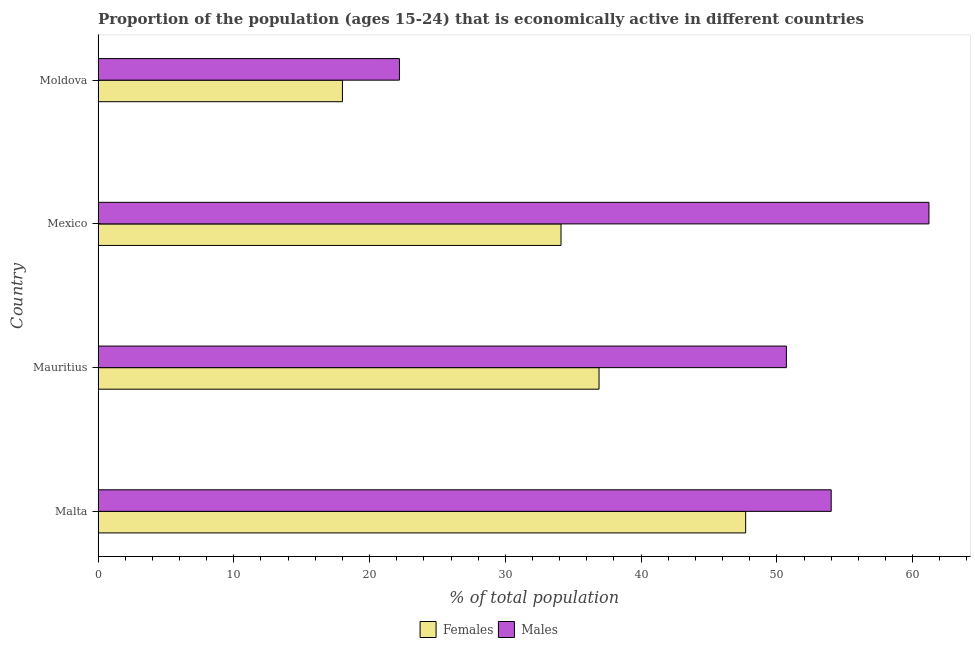How many different coloured bars are there?
Ensure brevity in your answer.  2. How many groups of bars are there?
Give a very brief answer. 4. Are the number of bars on each tick of the Y-axis equal?
Ensure brevity in your answer.  Yes. How many bars are there on the 4th tick from the top?
Provide a succinct answer. 2. What is the label of the 4th group of bars from the top?
Offer a terse response. Malta. In how many cases, is the number of bars for a given country not equal to the number of legend labels?
Offer a very short reply. 0. What is the percentage of economically active female population in Moldova?
Provide a short and direct response. 18. Across all countries, what is the maximum percentage of economically active male population?
Offer a terse response. 61.2. Across all countries, what is the minimum percentage of economically active female population?
Make the answer very short. 18. In which country was the percentage of economically active male population maximum?
Give a very brief answer. Mexico. In which country was the percentage of economically active female population minimum?
Your answer should be compact. Moldova. What is the total percentage of economically active male population in the graph?
Offer a terse response. 188.1. What is the difference between the percentage of economically active female population in Mexico and that in Moldova?
Keep it short and to the point. 16.1. What is the difference between the percentage of economically active male population in Moldova and the percentage of economically active female population in Malta?
Provide a short and direct response. -25.5. What is the average percentage of economically active female population per country?
Offer a terse response. 34.17. What is the ratio of the percentage of economically active female population in Malta to that in Mexico?
Your answer should be very brief. 1.4. Is the percentage of economically active female population in Mauritius less than that in Mexico?
Offer a very short reply. No. What is the difference between the highest and the second highest percentage of economically active female population?
Your response must be concise. 10.8. In how many countries, is the percentage of economically active female population greater than the average percentage of economically active female population taken over all countries?
Provide a short and direct response. 2. Is the sum of the percentage of economically active female population in Malta and Moldova greater than the maximum percentage of economically active male population across all countries?
Ensure brevity in your answer.  Yes. What does the 2nd bar from the top in Mexico represents?
Your response must be concise. Females. What does the 1st bar from the bottom in Mauritius represents?
Ensure brevity in your answer.  Females. How many bars are there?
Provide a succinct answer. 8. What is the difference between two consecutive major ticks on the X-axis?
Offer a very short reply. 10. Does the graph contain any zero values?
Provide a short and direct response. No. Does the graph contain grids?
Keep it short and to the point. No. Where does the legend appear in the graph?
Provide a succinct answer. Bottom center. How many legend labels are there?
Give a very brief answer. 2. What is the title of the graph?
Make the answer very short. Proportion of the population (ages 15-24) that is economically active in different countries. What is the label or title of the X-axis?
Provide a short and direct response. % of total population. What is the % of total population of Females in Malta?
Your answer should be very brief. 47.7. What is the % of total population in Females in Mauritius?
Make the answer very short. 36.9. What is the % of total population of Males in Mauritius?
Offer a very short reply. 50.7. What is the % of total population of Females in Mexico?
Ensure brevity in your answer.  34.1. What is the % of total population in Males in Mexico?
Offer a terse response. 61.2. What is the % of total population of Females in Moldova?
Provide a succinct answer. 18. What is the % of total population of Males in Moldova?
Provide a short and direct response. 22.2. Across all countries, what is the maximum % of total population of Females?
Provide a short and direct response. 47.7. Across all countries, what is the maximum % of total population of Males?
Provide a succinct answer. 61.2. Across all countries, what is the minimum % of total population in Males?
Provide a short and direct response. 22.2. What is the total % of total population of Females in the graph?
Your response must be concise. 136.7. What is the total % of total population in Males in the graph?
Your answer should be compact. 188.1. What is the difference between the % of total population in Females in Malta and that in Mauritius?
Provide a succinct answer. 10.8. What is the difference between the % of total population in Males in Malta and that in Mauritius?
Your answer should be compact. 3.3. What is the difference between the % of total population in Males in Malta and that in Mexico?
Your response must be concise. -7.2. What is the difference between the % of total population of Females in Malta and that in Moldova?
Offer a terse response. 29.7. What is the difference between the % of total population of Males in Malta and that in Moldova?
Keep it short and to the point. 31.8. What is the difference between the % of total population of Males in Mauritius and that in Mexico?
Offer a terse response. -10.5. What is the difference between the % of total population of Males in Mauritius and that in Moldova?
Offer a very short reply. 28.5. What is the difference between the % of total population of Females in Mexico and that in Moldova?
Your answer should be compact. 16.1. What is the difference between the % of total population in Females in Mauritius and the % of total population in Males in Mexico?
Offer a very short reply. -24.3. What is the average % of total population of Females per country?
Provide a short and direct response. 34.17. What is the average % of total population of Males per country?
Provide a short and direct response. 47.02. What is the difference between the % of total population in Females and % of total population in Males in Mexico?
Give a very brief answer. -27.1. What is the difference between the % of total population in Females and % of total population in Males in Moldova?
Your answer should be compact. -4.2. What is the ratio of the % of total population in Females in Malta to that in Mauritius?
Offer a very short reply. 1.29. What is the ratio of the % of total population of Males in Malta to that in Mauritius?
Provide a short and direct response. 1.07. What is the ratio of the % of total population of Females in Malta to that in Mexico?
Provide a short and direct response. 1.4. What is the ratio of the % of total population of Males in Malta to that in Mexico?
Offer a very short reply. 0.88. What is the ratio of the % of total population of Females in Malta to that in Moldova?
Your response must be concise. 2.65. What is the ratio of the % of total population of Males in Malta to that in Moldova?
Keep it short and to the point. 2.43. What is the ratio of the % of total population of Females in Mauritius to that in Mexico?
Provide a succinct answer. 1.08. What is the ratio of the % of total population in Males in Mauritius to that in Mexico?
Your answer should be very brief. 0.83. What is the ratio of the % of total population of Females in Mauritius to that in Moldova?
Give a very brief answer. 2.05. What is the ratio of the % of total population of Males in Mauritius to that in Moldova?
Your response must be concise. 2.28. What is the ratio of the % of total population of Females in Mexico to that in Moldova?
Your answer should be very brief. 1.89. What is the ratio of the % of total population in Males in Mexico to that in Moldova?
Offer a very short reply. 2.76. What is the difference between the highest and the lowest % of total population of Females?
Provide a succinct answer. 29.7. 